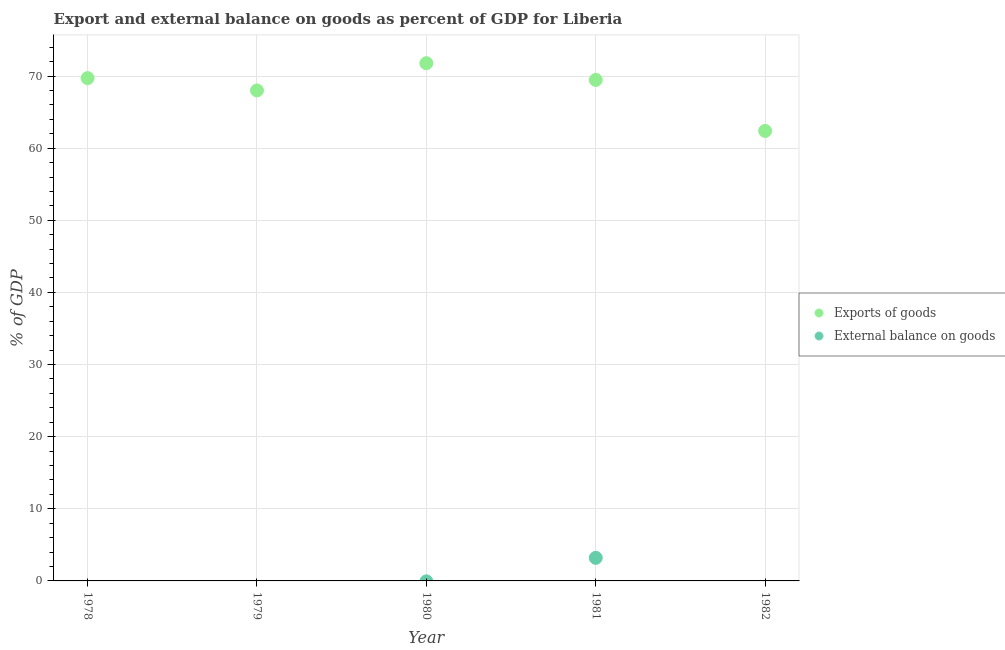Is the number of dotlines equal to the number of legend labels?
Your answer should be very brief. No. What is the export of goods as percentage of gdp in 1979?
Provide a succinct answer. 68. Across all years, what is the maximum export of goods as percentage of gdp?
Give a very brief answer. 71.78. Across all years, what is the minimum export of goods as percentage of gdp?
Your response must be concise. 62.39. What is the total external balance on goods as percentage of gdp in the graph?
Your answer should be compact. 3.2. What is the difference between the export of goods as percentage of gdp in 1978 and that in 1982?
Give a very brief answer. 7.32. What is the difference between the external balance on goods as percentage of gdp in 1978 and the export of goods as percentage of gdp in 1980?
Offer a terse response. -71.78. What is the average external balance on goods as percentage of gdp per year?
Provide a succinct answer. 0.64. In how many years, is the export of goods as percentage of gdp greater than 70 %?
Give a very brief answer. 1. What is the ratio of the export of goods as percentage of gdp in 1978 to that in 1981?
Offer a very short reply. 1. Is the export of goods as percentage of gdp in 1980 less than that in 1981?
Offer a very short reply. No. What is the difference between the highest and the second highest export of goods as percentage of gdp?
Your answer should be compact. 2.07. What is the difference between the highest and the lowest export of goods as percentage of gdp?
Give a very brief answer. 9.39. Does the export of goods as percentage of gdp monotonically increase over the years?
Give a very brief answer. No. How many dotlines are there?
Make the answer very short. 2. How many years are there in the graph?
Ensure brevity in your answer.  5. What is the difference between two consecutive major ticks on the Y-axis?
Your answer should be very brief. 10. Does the graph contain grids?
Provide a succinct answer. Yes. Where does the legend appear in the graph?
Make the answer very short. Center right. How are the legend labels stacked?
Offer a very short reply. Vertical. What is the title of the graph?
Your response must be concise. Export and external balance on goods as percent of GDP for Liberia. Does "Technicians" appear as one of the legend labels in the graph?
Your answer should be compact. No. What is the label or title of the X-axis?
Provide a succinct answer. Year. What is the label or title of the Y-axis?
Give a very brief answer. % of GDP. What is the % of GDP in Exports of goods in 1978?
Offer a terse response. 69.71. What is the % of GDP of External balance on goods in 1978?
Provide a succinct answer. 0. What is the % of GDP of Exports of goods in 1979?
Make the answer very short. 68. What is the % of GDP of Exports of goods in 1980?
Give a very brief answer. 71.78. What is the % of GDP in Exports of goods in 1981?
Give a very brief answer. 69.46. What is the % of GDP of External balance on goods in 1981?
Ensure brevity in your answer.  3.2. What is the % of GDP in Exports of goods in 1982?
Provide a short and direct response. 62.39. What is the % of GDP in External balance on goods in 1982?
Your answer should be very brief. 0. Across all years, what is the maximum % of GDP of Exports of goods?
Your response must be concise. 71.78. Across all years, what is the maximum % of GDP in External balance on goods?
Ensure brevity in your answer.  3.2. Across all years, what is the minimum % of GDP in Exports of goods?
Ensure brevity in your answer.  62.39. What is the total % of GDP of Exports of goods in the graph?
Offer a terse response. 341.34. What is the total % of GDP of External balance on goods in the graph?
Make the answer very short. 3.2. What is the difference between the % of GDP in Exports of goods in 1978 and that in 1979?
Your answer should be compact. 1.71. What is the difference between the % of GDP of Exports of goods in 1978 and that in 1980?
Your answer should be compact. -2.07. What is the difference between the % of GDP in Exports of goods in 1978 and that in 1981?
Provide a short and direct response. 0.25. What is the difference between the % of GDP in Exports of goods in 1978 and that in 1982?
Provide a succinct answer. 7.32. What is the difference between the % of GDP of Exports of goods in 1979 and that in 1980?
Your answer should be very brief. -3.77. What is the difference between the % of GDP of Exports of goods in 1979 and that in 1981?
Your response must be concise. -1.46. What is the difference between the % of GDP in Exports of goods in 1979 and that in 1982?
Provide a short and direct response. 5.62. What is the difference between the % of GDP in Exports of goods in 1980 and that in 1981?
Offer a very short reply. 2.32. What is the difference between the % of GDP of Exports of goods in 1980 and that in 1982?
Your answer should be compact. 9.39. What is the difference between the % of GDP in Exports of goods in 1981 and that in 1982?
Ensure brevity in your answer.  7.07. What is the difference between the % of GDP of Exports of goods in 1978 and the % of GDP of External balance on goods in 1981?
Keep it short and to the point. 66.51. What is the difference between the % of GDP in Exports of goods in 1979 and the % of GDP in External balance on goods in 1981?
Ensure brevity in your answer.  64.8. What is the difference between the % of GDP in Exports of goods in 1980 and the % of GDP in External balance on goods in 1981?
Your answer should be compact. 68.58. What is the average % of GDP in Exports of goods per year?
Your response must be concise. 68.27. What is the average % of GDP of External balance on goods per year?
Make the answer very short. 0.64. In the year 1981, what is the difference between the % of GDP of Exports of goods and % of GDP of External balance on goods?
Offer a terse response. 66.26. What is the ratio of the % of GDP of Exports of goods in 1978 to that in 1979?
Offer a very short reply. 1.03. What is the ratio of the % of GDP in Exports of goods in 1978 to that in 1980?
Your answer should be very brief. 0.97. What is the ratio of the % of GDP in Exports of goods in 1978 to that in 1982?
Your answer should be compact. 1.12. What is the ratio of the % of GDP in Exports of goods in 1979 to that in 1980?
Ensure brevity in your answer.  0.95. What is the ratio of the % of GDP in Exports of goods in 1979 to that in 1981?
Provide a short and direct response. 0.98. What is the ratio of the % of GDP of Exports of goods in 1979 to that in 1982?
Make the answer very short. 1.09. What is the ratio of the % of GDP in Exports of goods in 1980 to that in 1981?
Give a very brief answer. 1.03. What is the ratio of the % of GDP of Exports of goods in 1980 to that in 1982?
Ensure brevity in your answer.  1.15. What is the ratio of the % of GDP in Exports of goods in 1981 to that in 1982?
Make the answer very short. 1.11. What is the difference between the highest and the second highest % of GDP of Exports of goods?
Your answer should be compact. 2.07. What is the difference between the highest and the lowest % of GDP in Exports of goods?
Make the answer very short. 9.39. What is the difference between the highest and the lowest % of GDP in External balance on goods?
Ensure brevity in your answer.  3.2. 